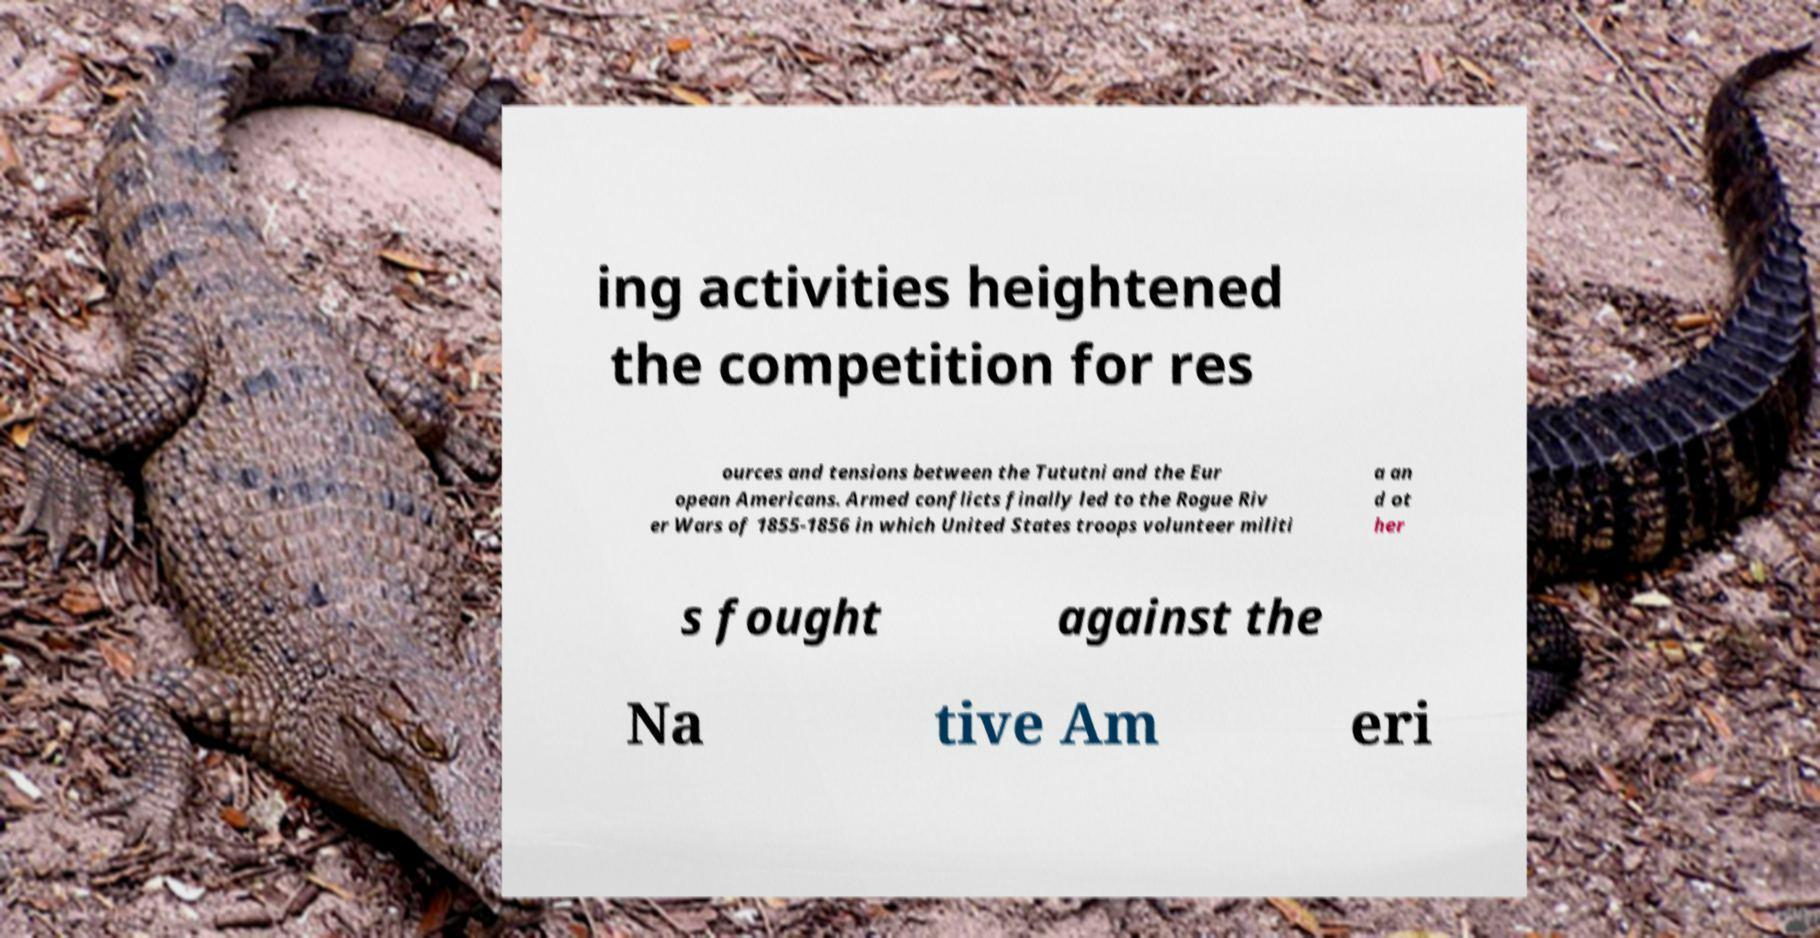There's text embedded in this image that I need extracted. Can you transcribe it verbatim? ing activities heightened the competition for res ources and tensions between the Tututni and the Eur opean Americans. Armed conflicts finally led to the Rogue Riv er Wars of 1855-1856 in which United States troops volunteer militi a an d ot her s fought against the Na tive Am eri 